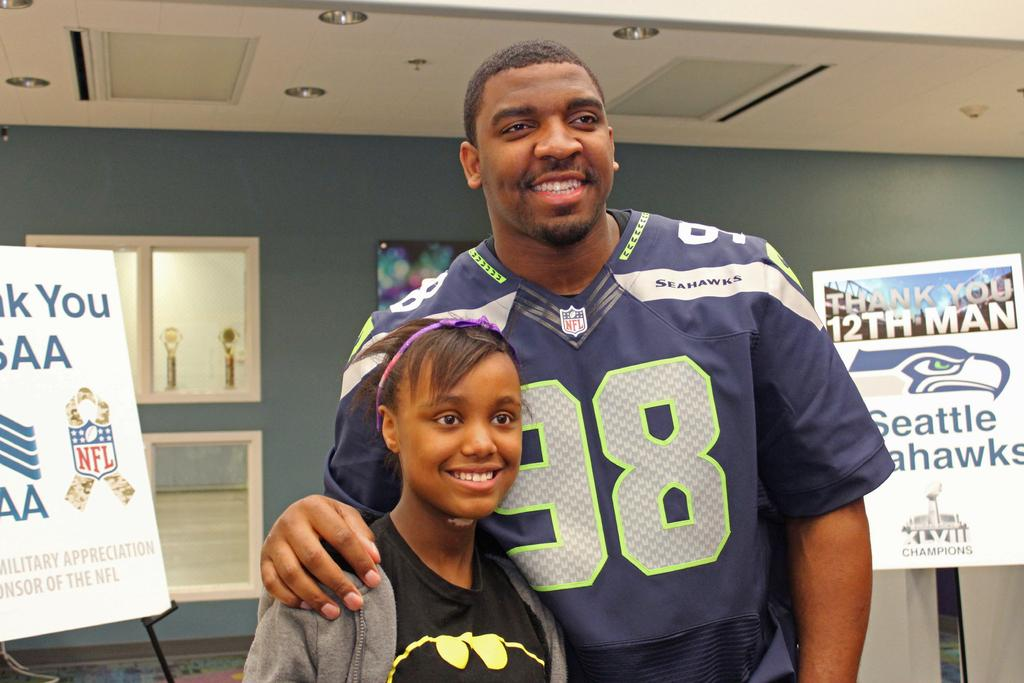<image>
Provide a brief description of the given image. Player wearing jersey 98 taking a picture with a girl. 